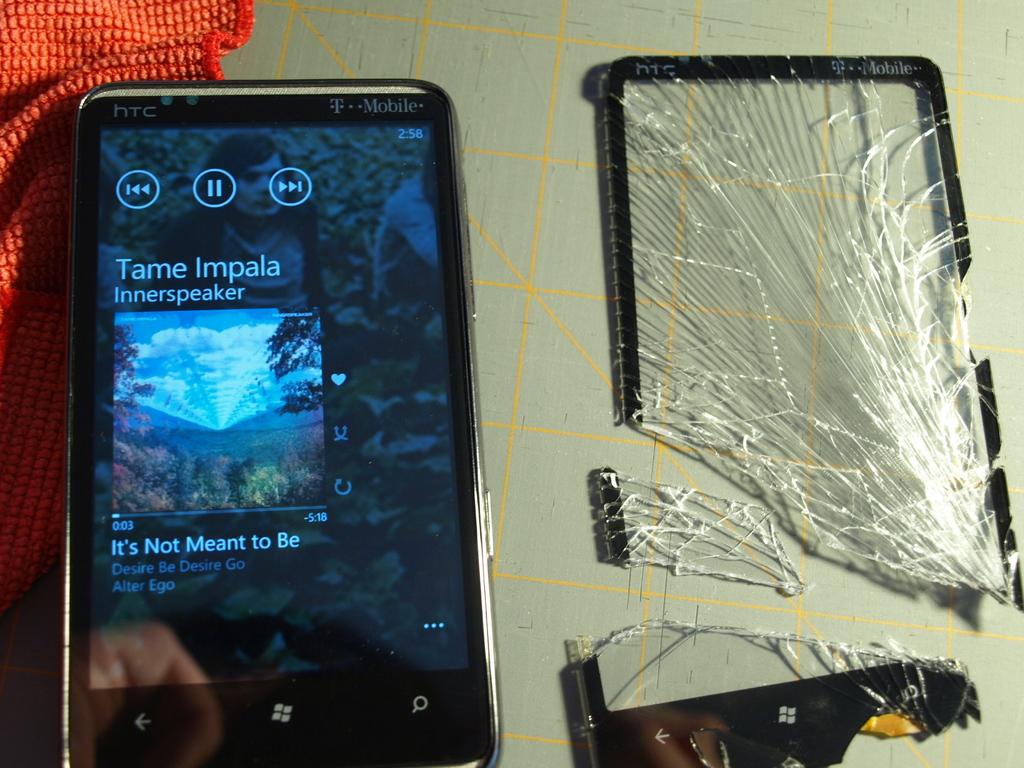What's the name of the song?
Give a very brief answer. It's not meant to be. What type of service does this person use?
Your answer should be very brief. T-mobile. 